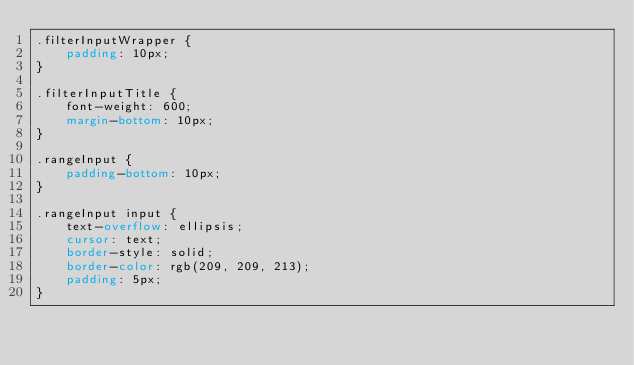<code> <loc_0><loc_0><loc_500><loc_500><_CSS_>.filterInputWrapper {
    padding: 10px;
}

.filterInputTitle {
    font-weight: 600;
    margin-bottom: 10px;
}

.rangeInput {
    padding-bottom: 10px;
}

.rangeInput input {
    text-overflow: ellipsis;
    cursor: text;
    border-style: solid;
    border-color: rgb(209, 209, 213);
    padding: 5px;
}
</code> 